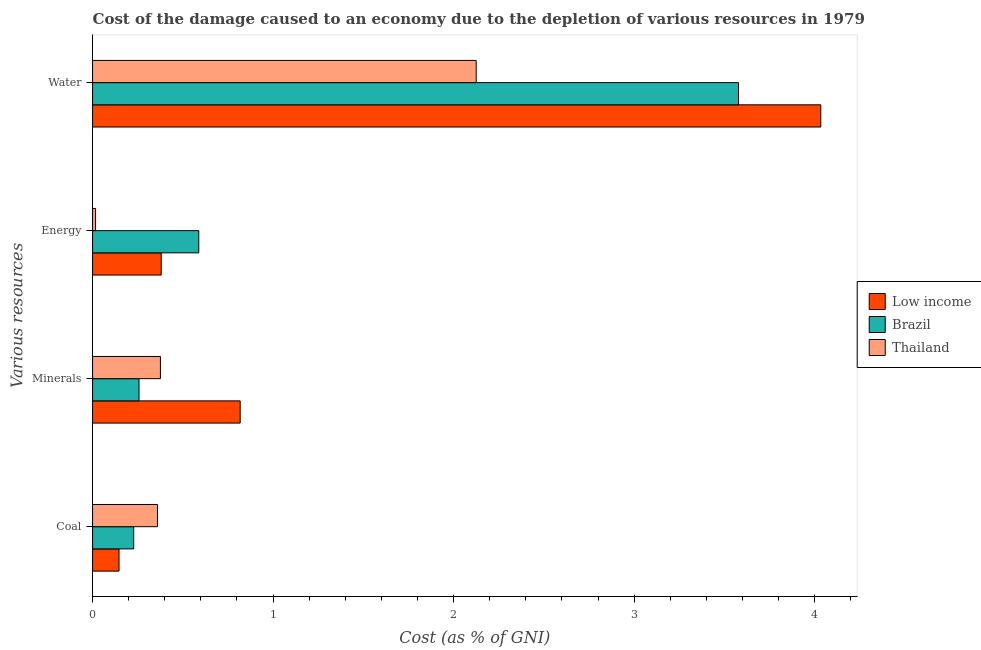How many groups of bars are there?
Your answer should be compact. 4. How many bars are there on the 3rd tick from the top?
Ensure brevity in your answer.  3. What is the label of the 1st group of bars from the top?
Offer a very short reply. Water. What is the cost of damage due to depletion of energy in Low income?
Your answer should be very brief. 0.38. Across all countries, what is the maximum cost of damage due to depletion of water?
Provide a short and direct response. 4.03. Across all countries, what is the minimum cost of damage due to depletion of coal?
Provide a short and direct response. 0.15. In which country was the cost of damage due to depletion of water minimum?
Make the answer very short. Thailand. What is the total cost of damage due to depletion of minerals in the graph?
Give a very brief answer. 1.45. What is the difference between the cost of damage due to depletion of coal in Thailand and that in Low income?
Your response must be concise. 0.21. What is the difference between the cost of damage due to depletion of water in Brazil and the cost of damage due to depletion of coal in Low income?
Offer a very short reply. 3.43. What is the average cost of damage due to depletion of minerals per country?
Give a very brief answer. 0.48. What is the difference between the cost of damage due to depletion of minerals and cost of damage due to depletion of coal in Thailand?
Your answer should be very brief. 0.02. In how many countries, is the cost of damage due to depletion of water greater than 1.6 %?
Offer a terse response. 3. What is the ratio of the cost of damage due to depletion of coal in Low income to that in Thailand?
Provide a short and direct response. 0.41. Is the cost of damage due to depletion of energy in Low income less than that in Thailand?
Offer a terse response. No. Is the difference between the cost of damage due to depletion of energy in Low income and Thailand greater than the difference between the cost of damage due to depletion of minerals in Low income and Thailand?
Provide a succinct answer. No. What is the difference between the highest and the second highest cost of damage due to depletion of minerals?
Your response must be concise. 0.44. What is the difference between the highest and the lowest cost of damage due to depletion of coal?
Ensure brevity in your answer.  0.21. In how many countries, is the cost of damage due to depletion of minerals greater than the average cost of damage due to depletion of minerals taken over all countries?
Your response must be concise. 1. Is the sum of the cost of damage due to depletion of coal in Thailand and Low income greater than the maximum cost of damage due to depletion of energy across all countries?
Ensure brevity in your answer.  No. What does the 3rd bar from the top in Water represents?
Your answer should be very brief. Low income. What does the 3rd bar from the bottom in Minerals represents?
Your answer should be compact. Thailand. Is it the case that in every country, the sum of the cost of damage due to depletion of coal and cost of damage due to depletion of minerals is greater than the cost of damage due to depletion of energy?
Provide a succinct answer. No. How many bars are there?
Offer a very short reply. 12. Are all the bars in the graph horizontal?
Offer a very short reply. Yes. How many countries are there in the graph?
Your answer should be very brief. 3. Are the values on the major ticks of X-axis written in scientific E-notation?
Your response must be concise. No. What is the title of the graph?
Your answer should be very brief. Cost of the damage caused to an economy due to the depletion of various resources in 1979 . What is the label or title of the X-axis?
Make the answer very short. Cost (as % of GNI). What is the label or title of the Y-axis?
Offer a very short reply. Various resources. What is the Cost (as % of GNI) in Low income in Coal?
Give a very brief answer. 0.15. What is the Cost (as % of GNI) of Brazil in Coal?
Your answer should be compact. 0.23. What is the Cost (as % of GNI) of Thailand in Coal?
Provide a succinct answer. 0.36. What is the Cost (as % of GNI) in Low income in Minerals?
Offer a very short reply. 0.82. What is the Cost (as % of GNI) of Brazil in Minerals?
Provide a succinct answer. 0.26. What is the Cost (as % of GNI) in Thailand in Minerals?
Offer a very short reply. 0.38. What is the Cost (as % of GNI) of Low income in Energy?
Keep it short and to the point. 0.38. What is the Cost (as % of GNI) of Brazil in Energy?
Keep it short and to the point. 0.59. What is the Cost (as % of GNI) of Thailand in Energy?
Your answer should be very brief. 0.02. What is the Cost (as % of GNI) of Low income in Water?
Offer a very short reply. 4.03. What is the Cost (as % of GNI) of Brazil in Water?
Your answer should be very brief. 3.58. What is the Cost (as % of GNI) in Thailand in Water?
Provide a succinct answer. 2.13. Across all Various resources, what is the maximum Cost (as % of GNI) in Low income?
Your answer should be very brief. 4.03. Across all Various resources, what is the maximum Cost (as % of GNI) of Brazil?
Keep it short and to the point. 3.58. Across all Various resources, what is the maximum Cost (as % of GNI) of Thailand?
Keep it short and to the point. 2.13. Across all Various resources, what is the minimum Cost (as % of GNI) of Low income?
Provide a short and direct response. 0.15. Across all Various resources, what is the minimum Cost (as % of GNI) in Brazil?
Offer a very short reply. 0.23. Across all Various resources, what is the minimum Cost (as % of GNI) in Thailand?
Ensure brevity in your answer.  0.02. What is the total Cost (as % of GNI) of Low income in the graph?
Keep it short and to the point. 5.38. What is the total Cost (as % of GNI) in Brazil in the graph?
Ensure brevity in your answer.  4.65. What is the total Cost (as % of GNI) in Thailand in the graph?
Give a very brief answer. 2.88. What is the difference between the Cost (as % of GNI) of Low income in Coal and that in Minerals?
Your answer should be very brief. -0.67. What is the difference between the Cost (as % of GNI) in Brazil in Coal and that in Minerals?
Your response must be concise. -0.03. What is the difference between the Cost (as % of GNI) in Thailand in Coal and that in Minerals?
Make the answer very short. -0.02. What is the difference between the Cost (as % of GNI) in Low income in Coal and that in Energy?
Offer a very short reply. -0.23. What is the difference between the Cost (as % of GNI) of Brazil in Coal and that in Energy?
Your answer should be compact. -0.36. What is the difference between the Cost (as % of GNI) in Thailand in Coal and that in Energy?
Offer a very short reply. 0.34. What is the difference between the Cost (as % of GNI) in Low income in Coal and that in Water?
Offer a very short reply. -3.89. What is the difference between the Cost (as % of GNI) of Brazil in Coal and that in Water?
Give a very brief answer. -3.35. What is the difference between the Cost (as % of GNI) of Thailand in Coal and that in Water?
Offer a terse response. -1.77. What is the difference between the Cost (as % of GNI) in Low income in Minerals and that in Energy?
Keep it short and to the point. 0.44. What is the difference between the Cost (as % of GNI) in Brazil in Minerals and that in Energy?
Provide a succinct answer. -0.33. What is the difference between the Cost (as % of GNI) in Thailand in Minerals and that in Energy?
Ensure brevity in your answer.  0.36. What is the difference between the Cost (as % of GNI) of Low income in Minerals and that in Water?
Make the answer very short. -3.22. What is the difference between the Cost (as % of GNI) in Brazil in Minerals and that in Water?
Make the answer very short. -3.32. What is the difference between the Cost (as % of GNI) in Thailand in Minerals and that in Water?
Provide a short and direct response. -1.75. What is the difference between the Cost (as % of GNI) of Low income in Energy and that in Water?
Make the answer very short. -3.65. What is the difference between the Cost (as % of GNI) in Brazil in Energy and that in Water?
Provide a short and direct response. -2.99. What is the difference between the Cost (as % of GNI) in Thailand in Energy and that in Water?
Your answer should be very brief. -2.11. What is the difference between the Cost (as % of GNI) of Low income in Coal and the Cost (as % of GNI) of Brazil in Minerals?
Offer a very short reply. -0.11. What is the difference between the Cost (as % of GNI) of Low income in Coal and the Cost (as % of GNI) of Thailand in Minerals?
Your response must be concise. -0.23. What is the difference between the Cost (as % of GNI) of Brazil in Coal and the Cost (as % of GNI) of Thailand in Minerals?
Make the answer very short. -0.15. What is the difference between the Cost (as % of GNI) in Low income in Coal and the Cost (as % of GNI) in Brazil in Energy?
Keep it short and to the point. -0.44. What is the difference between the Cost (as % of GNI) of Low income in Coal and the Cost (as % of GNI) of Thailand in Energy?
Your response must be concise. 0.13. What is the difference between the Cost (as % of GNI) of Brazil in Coal and the Cost (as % of GNI) of Thailand in Energy?
Ensure brevity in your answer.  0.21. What is the difference between the Cost (as % of GNI) in Low income in Coal and the Cost (as % of GNI) in Brazil in Water?
Make the answer very short. -3.43. What is the difference between the Cost (as % of GNI) of Low income in Coal and the Cost (as % of GNI) of Thailand in Water?
Keep it short and to the point. -1.98. What is the difference between the Cost (as % of GNI) of Brazil in Coal and the Cost (as % of GNI) of Thailand in Water?
Your answer should be compact. -1.9. What is the difference between the Cost (as % of GNI) in Low income in Minerals and the Cost (as % of GNI) in Brazil in Energy?
Provide a short and direct response. 0.23. What is the difference between the Cost (as % of GNI) in Low income in Minerals and the Cost (as % of GNI) in Thailand in Energy?
Keep it short and to the point. 0.8. What is the difference between the Cost (as % of GNI) of Brazil in Minerals and the Cost (as % of GNI) of Thailand in Energy?
Give a very brief answer. 0.24. What is the difference between the Cost (as % of GNI) of Low income in Minerals and the Cost (as % of GNI) of Brazil in Water?
Provide a succinct answer. -2.76. What is the difference between the Cost (as % of GNI) of Low income in Minerals and the Cost (as % of GNI) of Thailand in Water?
Provide a succinct answer. -1.31. What is the difference between the Cost (as % of GNI) in Brazil in Minerals and the Cost (as % of GNI) in Thailand in Water?
Make the answer very short. -1.87. What is the difference between the Cost (as % of GNI) in Low income in Energy and the Cost (as % of GNI) in Brazil in Water?
Your response must be concise. -3.2. What is the difference between the Cost (as % of GNI) of Low income in Energy and the Cost (as % of GNI) of Thailand in Water?
Give a very brief answer. -1.74. What is the difference between the Cost (as % of GNI) in Brazil in Energy and the Cost (as % of GNI) in Thailand in Water?
Offer a very short reply. -1.54. What is the average Cost (as % of GNI) in Low income per Various resources?
Your answer should be compact. 1.34. What is the average Cost (as % of GNI) of Brazil per Various resources?
Offer a very short reply. 1.16. What is the average Cost (as % of GNI) of Thailand per Various resources?
Make the answer very short. 0.72. What is the difference between the Cost (as % of GNI) of Low income and Cost (as % of GNI) of Brazil in Coal?
Ensure brevity in your answer.  -0.08. What is the difference between the Cost (as % of GNI) in Low income and Cost (as % of GNI) in Thailand in Coal?
Make the answer very short. -0.21. What is the difference between the Cost (as % of GNI) in Brazil and Cost (as % of GNI) in Thailand in Coal?
Ensure brevity in your answer.  -0.13. What is the difference between the Cost (as % of GNI) in Low income and Cost (as % of GNI) in Brazil in Minerals?
Give a very brief answer. 0.56. What is the difference between the Cost (as % of GNI) in Low income and Cost (as % of GNI) in Thailand in Minerals?
Provide a succinct answer. 0.44. What is the difference between the Cost (as % of GNI) in Brazil and Cost (as % of GNI) in Thailand in Minerals?
Make the answer very short. -0.12. What is the difference between the Cost (as % of GNI) of Low income and Cost (as % of GNI) of Brazil in Energy?
Offer a terse response. -0.21. What is the difference between the Cost (as % of GNI) in Low income and Cost (as % of GNI) in Thailand in Energy?
Provide a short and direct response. 0.36. What is the difference between the Cost (as % of GNI) of Brazil and Cost (as % of GNI) of Thailand in Energy?
Your response must be concise. 0.57. What is the difference between the Cost (as % of GNI) of Low income and Cost (as % of GNI) of Brazil in Water?
Provide a short and direct response. 0.46. What is the difference between the Cost (as % of GNI) in Low income and Cost (as % of GNI) in Thailand in Water?
Ensure brevity in your answer.  1.91. What is the difference between the Cost (as % of GNI) in Brazil and Cost (as % of GNI) in Thailand in Water?
Ensure brevity in your answer.  1.45. What is the ratio of the Cost (as % of GNI) in Low income in Coal to that in Minerals?
Provide a succinct answer. 0.18. What is the ratio of the Cost (as % of GNI) of Brazil in Coal to that in Minerals?
Your answer should be very brief. 0.89. What is the ratio of the Cost (as % of GNI) in Thailand in Coal to that in Minerals?
Make the answer very short. 0.96. What is the ratio of the Cost (as % of GNI) of Low income in Coal to that in Energy?
Ensure brevity in your answer.  0.39. What is the ratio of the Cost (as % of GNI) in Brazil in Coal to that in Energy?
Your answer should be very brief. 0.39. What is the ratio of the Cost (as % of GNI) of Thailand in Coal to that in Energy?
Give a very brief answer. 21.69. What is the ratio of the Cost (as % of GNI) in Low income in Coal to that in Water?
Your answer should be very brief. 0.04. What is the ratio of the Cost (as % of GNI) of Brazil in Coal to that in Water?
Offer a terse response. 0.06. What is the ratio of the Cost (as % of GNI) of Thailand in Coal to that in Water?
Provide a short and direct response. 0.17. What is the ratio of the Cost (as % of GNI) in Low income in Minerals to that in Energy?
Ensure brevity in your answer.  2.15. What is the ratio of the Cost (as % of GNI) in Brazil in Minerals to that in Energy?
Your answer should be very brief. 0.44. What is the ratio of the Cost (as % of GNI) of Thailand in Minerals to that in Energy?
Ensure brevity in your answer.  22.67. What is the ratio of the Cost (as % of GNI) of Low income in Minerals to that in Water?
Offer a terse response. 0.2. What is the ratio of the Cost (as % of GNI) of Brazil in Minerals to that in Water?
Offer a very short reply. 0.07. What is the ratio of the Cost (as % of GNI) of Thailand in Minerals to that in Water?
Provide a short and direct response. 0.18. What is the ratio of the Cost (as % of GNI) of Low income in Energy to that in Water?
Keep it short and to the point. 0.09. What is the ratio of the Cost (as % of GNI) of Brazil in Energy to that in Water?
Your response must be concise. 0.16. What is the ratio of the Cost (as % of GNI) in Thailand in Energy to that in Water?
Your answer should be compact. 0.01. What is the difference between the highest and the second highest Cost (as % of GNI) of Low income?
Give a very brief answer. 3.22. What is the difference between the highest and the second highest Cost (as % of GNI) in Brazil?
Keep it short and to the point. 2.99. What is the difference between the highest and the second highest Cost (as % of GNI) in Thailand?
Offer a terse response. 1.75. What is the difference between the highest and the lowest Cost (as % of GNI) in Low income?
Your response must be concise. 3.89. What is the difference between the highest and the lowest Cost (as % of GNI) in Brazil?
Provide a short and direct response. 3.35. What is the difference between the highest and the lowest Cost (as % of GNI) of Thailand?
Keep it short and to the point. 2.11. 